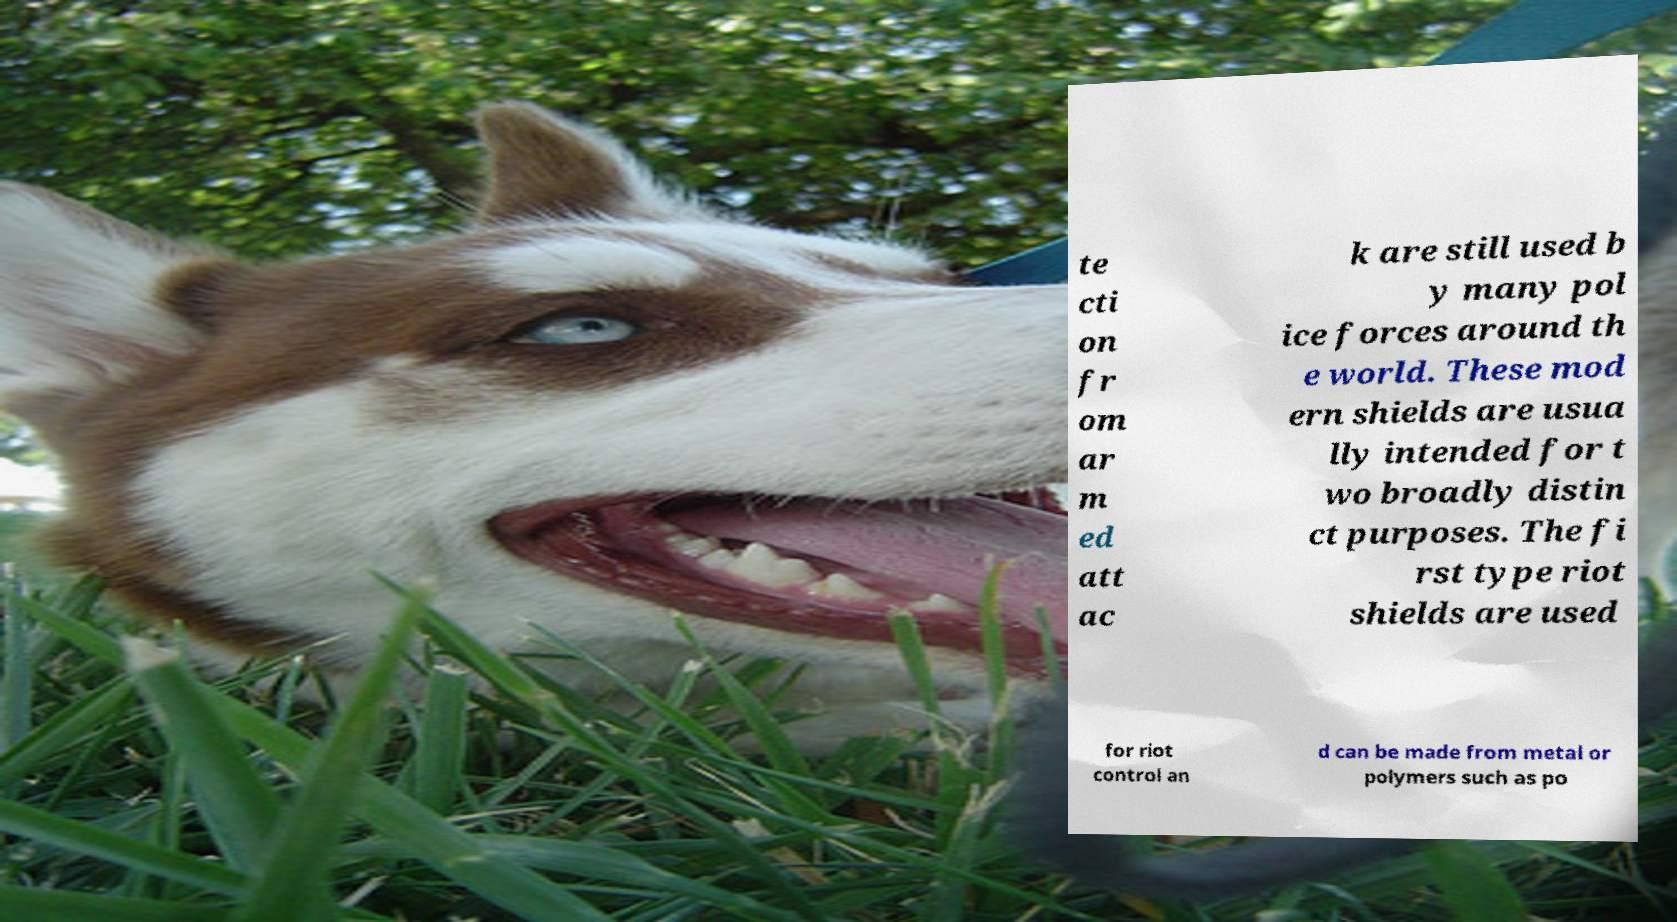Could you assist in decoding the text presented in this image and type it out clearly? te cti on fr om ar m ed att ac k are still used b y many pol ice forces around th e world. These mod ern shields are usua lly intended for t wo broadly distin ct purposes. The fi rst type riot shields are used for riot control an d can be made from metal or polymers such as po 